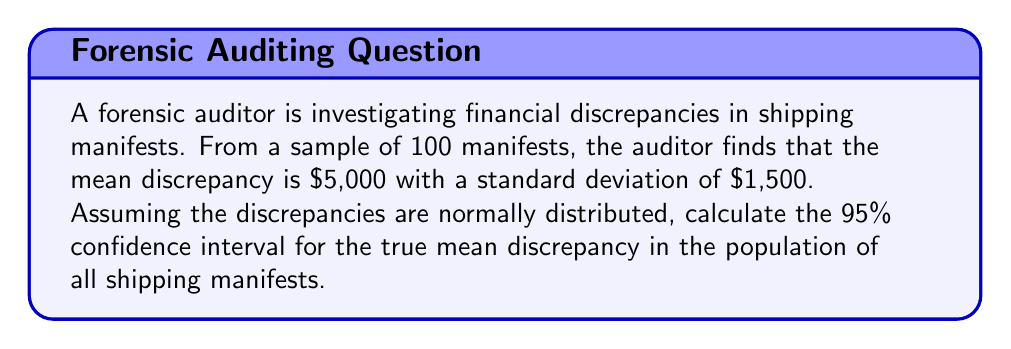Provide a solution to this math problem. To calculate the confidence interval, we'll follow these steps:

1) The formula for the confidence interval is:

   $$\bar{x} \pm z_{\alpha/2} \cdot \frac{\sigma}{\sqrt{n}}$$

   where:
   $\bar{x}$ is the sample mean
   $z_{\alpha/2}$ is the z-score for the desired confidence level
   $\sigma$ is the population standard deviation
   $n$ is the sample size

2) We know:
   $\bar{x} = \$5,000$
   $\sigma = \$1,500$ (we assume the sample standard deviation approximates the population standard deviation)
   $n = 100$
   For a 95% confidence interval, $z_{\alpha/2} = 1.96$

3) Substituting these values into the formula:

   $$5000 \pm 1.96 \cdot \frac{1500}{\sqrt{100}}$$

4) Simplify:
   $$5000 \pm 1.96 \cdot 150$$
   $$5000 \pm 294$$

5) Calculate the interval:
   Lower bound: $5000 - 294 = 4706$
   Upper bound: $5000 + 294 = 5294$

Therefore, we can be 95% confident that the true mean discrepancy in the population of all shipping manifests falls between $4,706 and $5,294.
Answer: ($4,706, $5,294) 